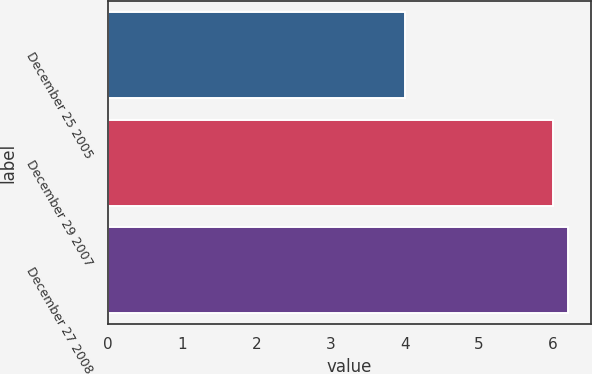Convert chart. <chart><loc_0><loc_0><loc_500><loc_500><bar_chart><fcel>December 25 2005<fcel>December 29 2007<fcel>December 27 2008<nl><fcel>4<fcel>6<fcel>6.2<nl></chart> 